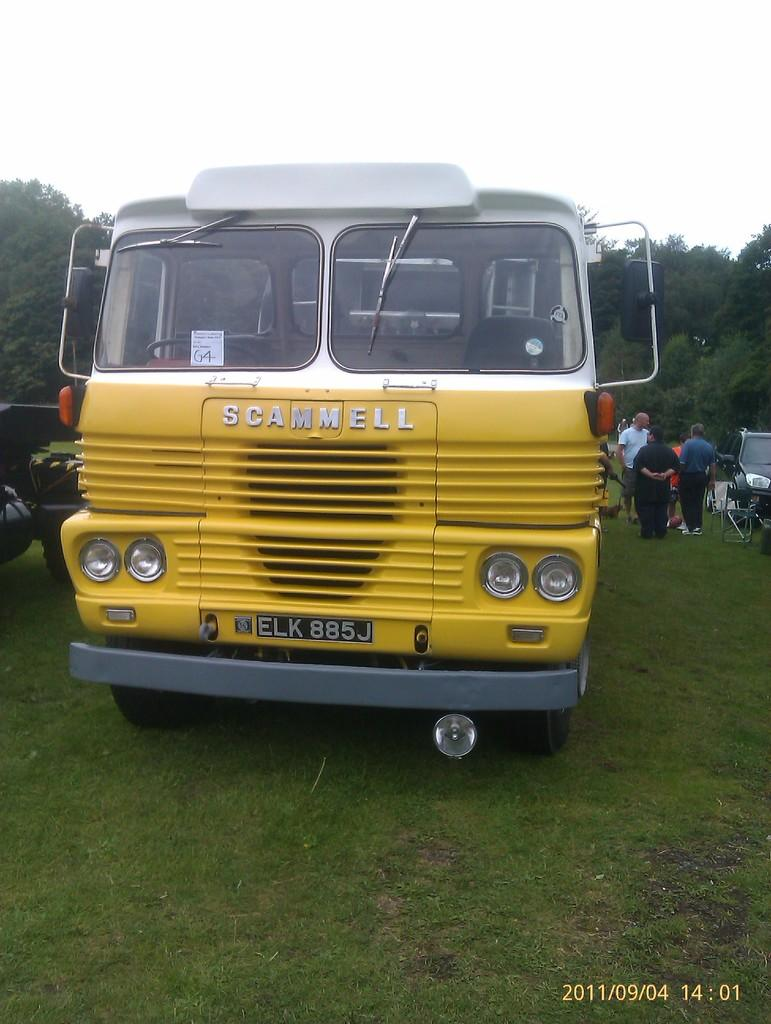What is the main subject of the image? The main subject of the image is a bus. Where is the bus located in the image? The bus is on the ground in the image. What else can be seen near the bus? There are people standing beside the bus. What other vehicles are visible in the image? There is a car on the right side of the image. What can be seen in the background of the image? There are trees and the sky visible in the background of the image. What type of jam is being spread on the bus in the image? There is no jam present in the image, and the bus is not being used as a surface for spreading jam. 